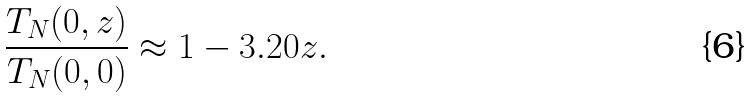<formula> <loc_0><loc_0><loc_500><loc_500>\frac { T _ { N } ( 0 , z ) } { T _ { N } ( 0 , 0 ) } \approx 1 - 3 . 2 0 z .</formula> 